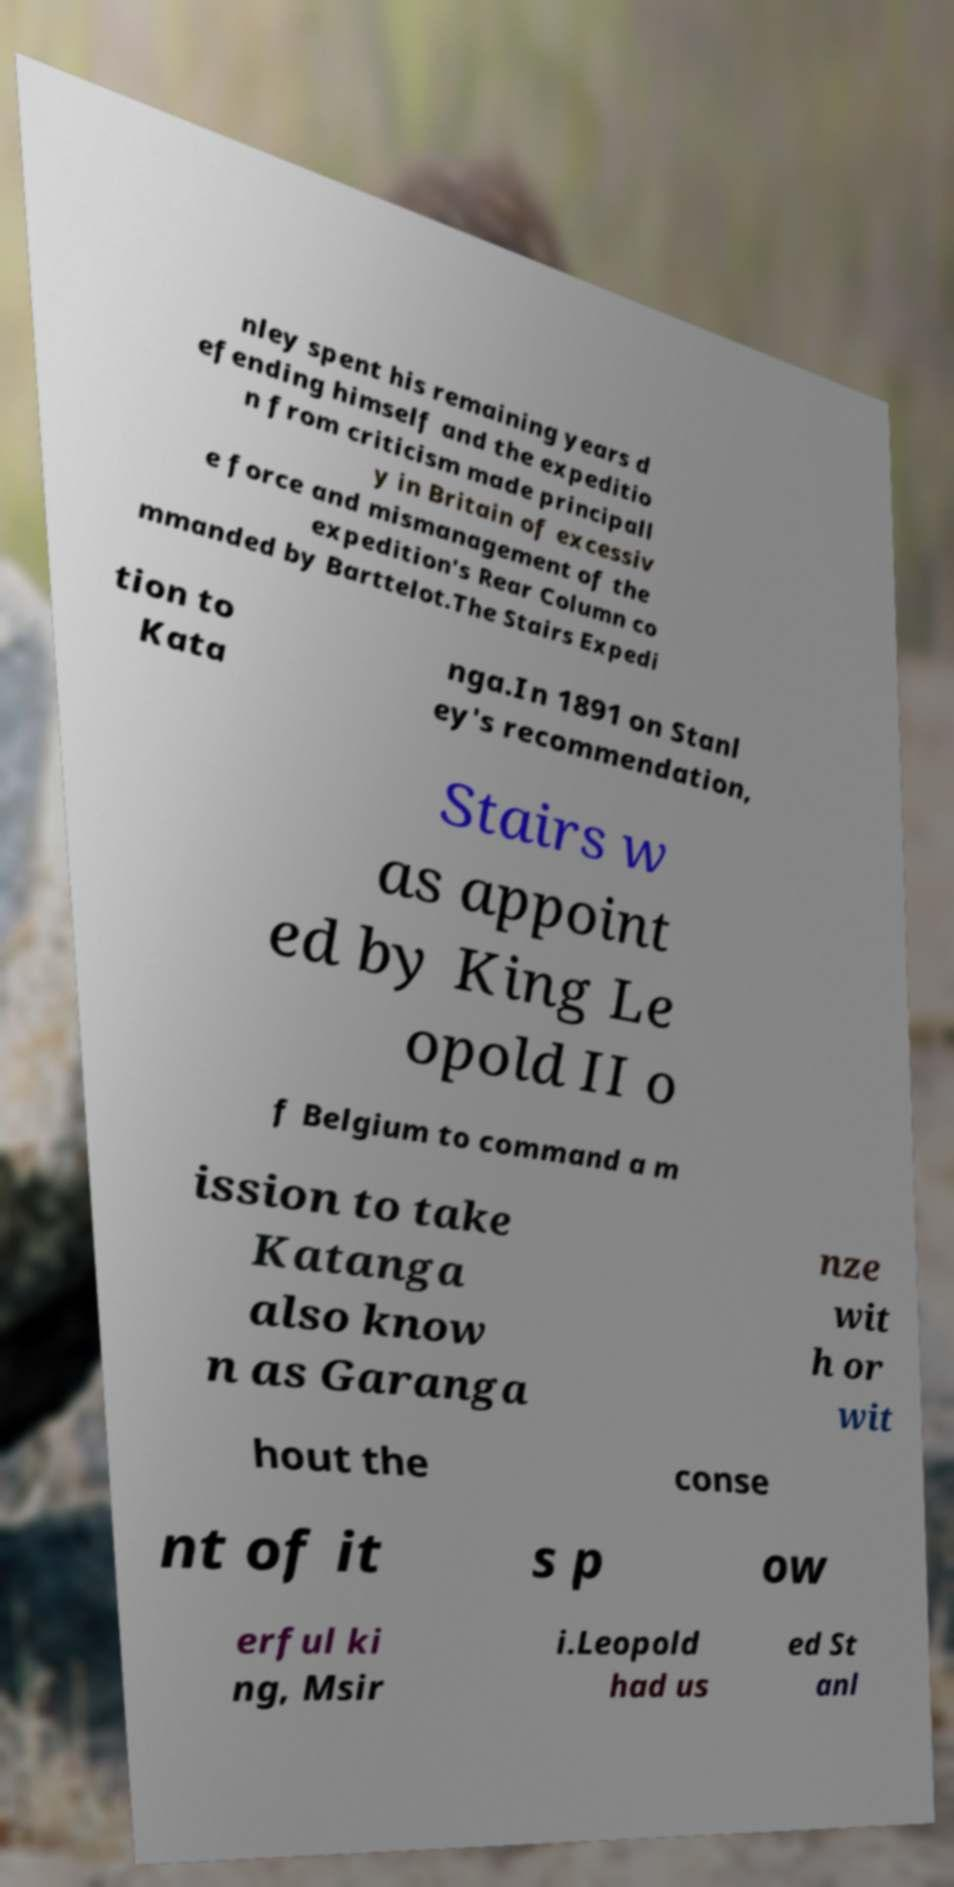For documentation purposes, I need the text within this image transcribed. Could you provide that? nley spent his remaining years d efending himself and the expeditio n from criticism made principall y in Britain of excessiv e force and mismanagement of the expedition's Rear Column co mmanded by Barttelot.The Stairs Expedi tion to Kata nga.In 1891 on Stanl ey's recommendation, Stairs w as appoint ed by King Le opold II o f Belgium to command a m ission to take Katanga also know n as Garanga nze wit h or wit hout the conse nt of it s p ow erful ki ng, Msir i.Leopold had us ed St anl 